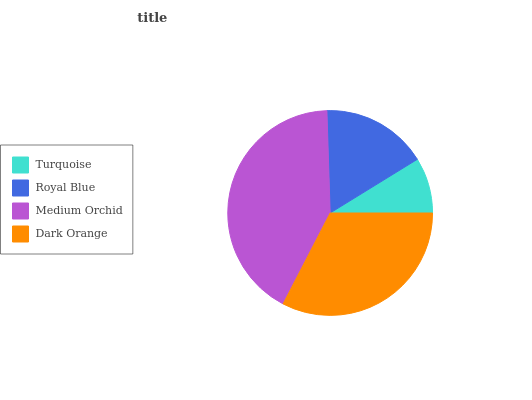Is Turquoise the minimum?
Answer yes or no. Yes. Is Medium Orchid the maximum?
Answer yes or no. Yes. Is Royal Blue the minimum?
Answer yes or no. No. Is Royal Blue the maximum?
Answer yes or no. No. Is Royal Blue greater than Turquoise?
Answer yes or no. Yes. Is Turquoise less than Royal Blue?
Answer yes or no. Yes. Is Turquoise greater than Royal Blue?
Answer yes or no. No. Is Royal Blue less than Turquoise?
Answer yes or no. No. Is Dark Orange the high median?
Answer yes or no. Yes. Is Royal Blue the low median?
Answer yes or no. Yes. Is Royal Blue the high median?
Answer yes or no. No. Is Turquoise the low median?
Answer yes or no. No. 